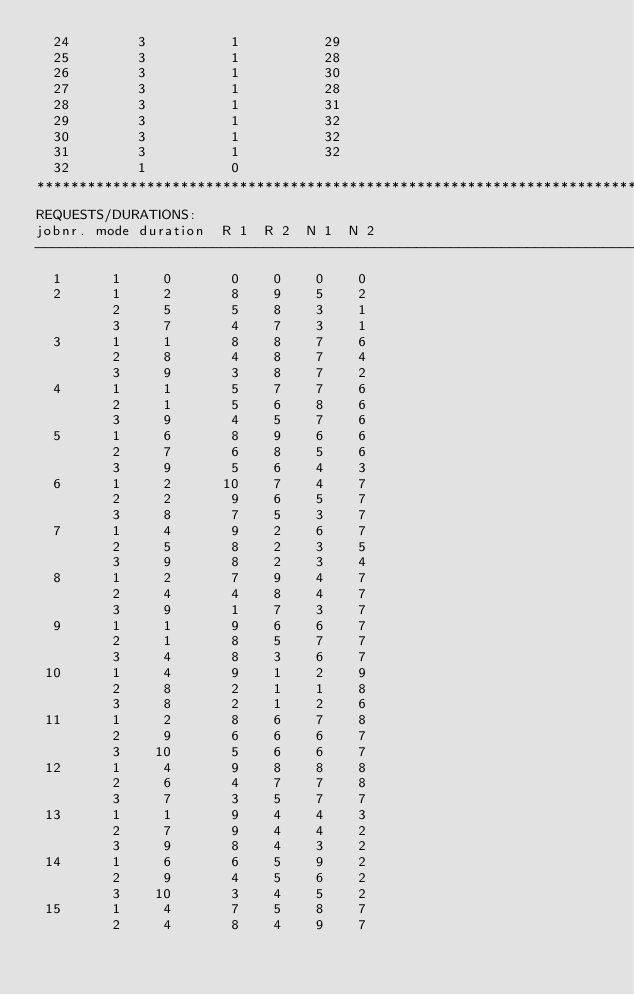Convert code to text. <code><loc_0><loc_0><loc_500><loc_500><_ObjectiveC_>  24        3          1          29
  25        3          1          28
  26        3          1          30
  27        3          1          28
  28        3          1          31
  29        3          1          32
  30        3          1          32
  31        3          1          32
  32        1          0        
************************************************************************
REQUESTS/DURATIONS:
jobnr. mode duration  R 1  R 2  N 1  N 2
------------------------------------------------------------------------
  1      1     0       0    0    0    0
  2      1     2       8    9    5    2
         2     5       5    8    3    1
         3     7       4    7    3    1
  3      1     1       8    8    7    6
         2     8       4    8    7    4
         3     9       3    8    7    2
  4      1     1       5    7    7    6
         2     1       5    6    8    6
         3     9       4    5    7    6
  5      1     6       8    9    6    6
         2     7       6    8    5    6
         3     9       5    6    4    3
  6      1     2      10    7    4    7
         2     2       9    6    5    7
         3     8       7    5    3    7
  7      1     4       9    2    6    7
         2     5       8    2    3    5
         3     9       8    2    3    4
  8      1     2       7    9    4    7
         2     4       4    8    4    7
         3     9       1    7    3    7
  9      1     1       9    6    6    7
         2     1       8    5    7    7
         3     4       8    3    6    7
 10      1     4       9    1    2    9
         2     8       2    1    1    8
         3     8       2    1    2    6
 11      1     2       8    6    7    8
         2     9       6    6    6    7
         3    10       5    6    6    7
 12      1     4       9    8    8    8
         2     6       4    7    7    8
         3     7       3    5    7    7
 13      1     1       9    4    4    3
         2     7       9    4    4    2
         3     9       8    4    3    2
 14      1     6       6    5    9    2
         2     9       4    5    6    2
         3    10       3    4    5    2
 15      1     4       7    5    8    7
         2     4       8    4    9    7</code> 